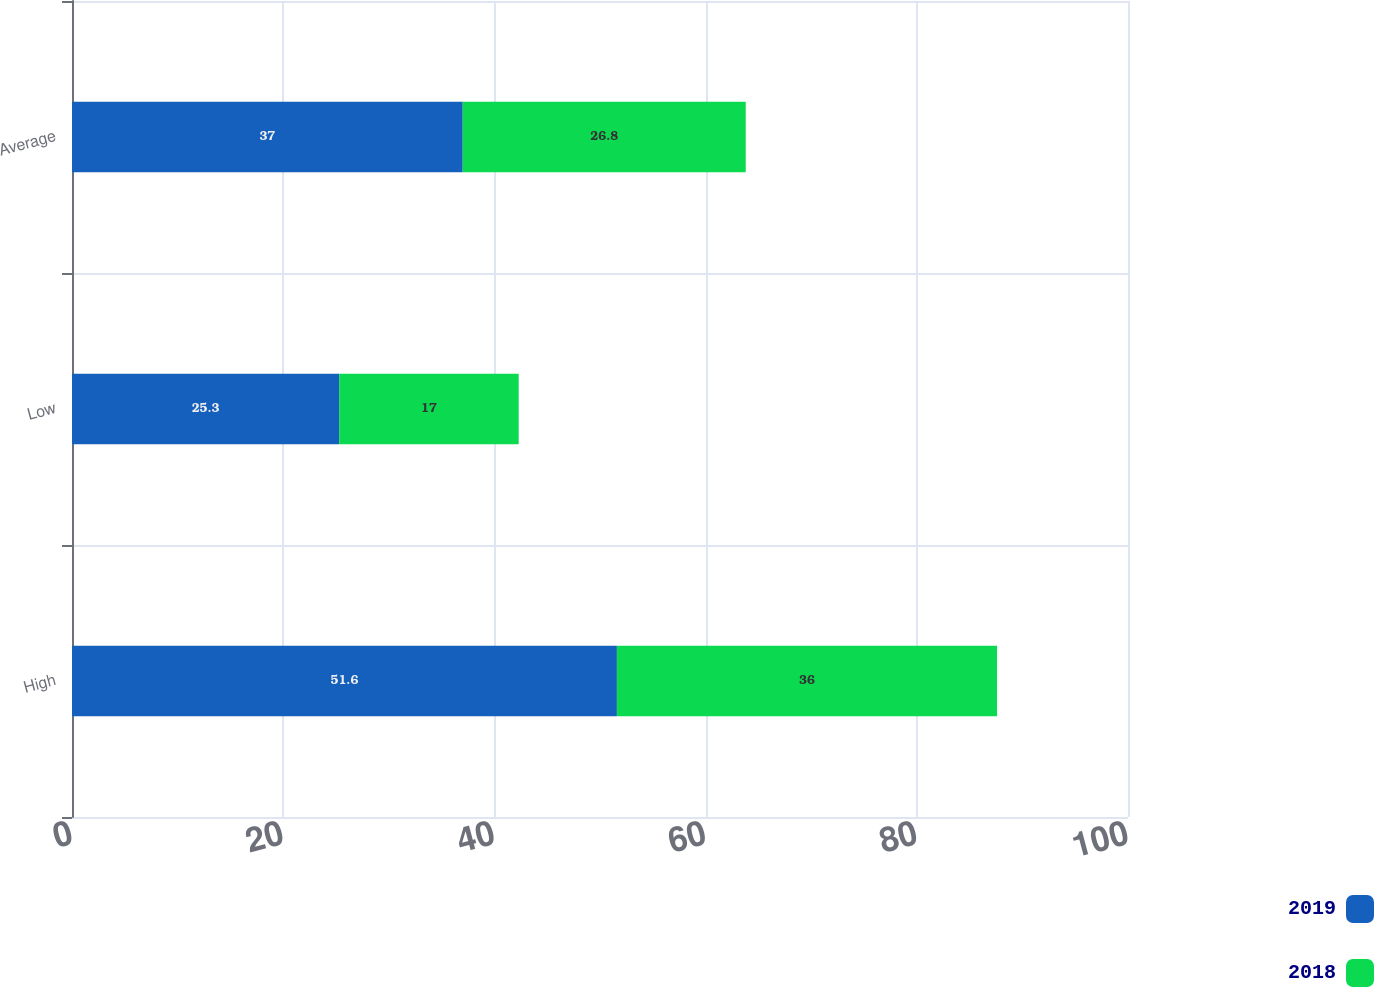Convert chart to OTSL. <chart><loc_0><loc_0><loc_500><loc_500><stacked_bar_chart><ecel><fcel>High<fcel>Low<fcel>Average<nl><fcel>2019<fcel>51.6<fcel>25.3<fcel>37<nl><fcel>2018<fcel>36<fcel>17<fcel>26.8<nl></chart> 